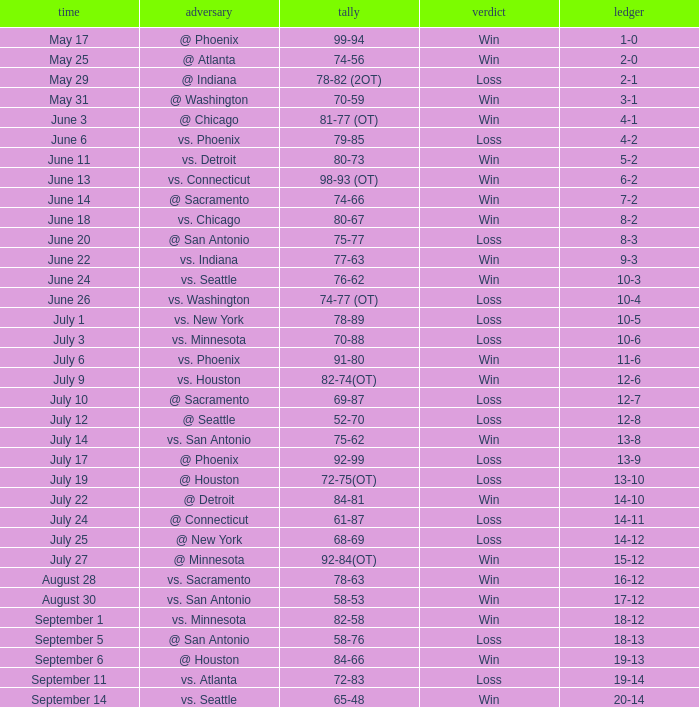What is the Record of the game with a Score of 65-48? 20-14. 